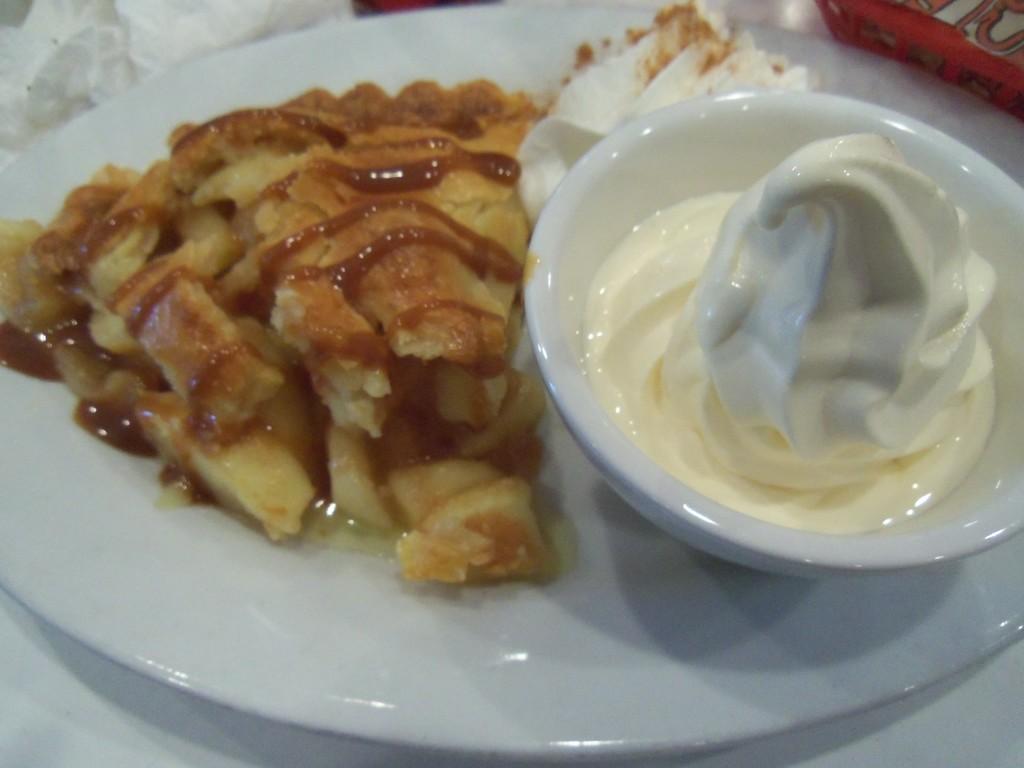Please provide a concise description of this image. On the table i can see white plate, cup, paper, red box. In the plate i can see sauce, ice cream and food item. In a bowl there is a ice cream. 